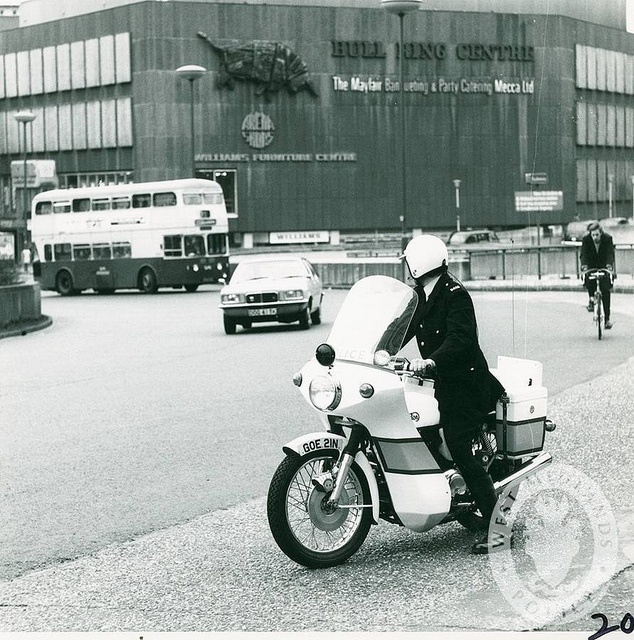Describe the objects in this image and their specific colors. I can see motorcycle in white, black, darkgray, and gray tones, bus in white, black, gray, and darkgray tones, people in white, black, darkgray, and gray tones, car in white, black, darkgray, and gray tones, and people in white, black, gray, darkgray, and lightgray tones in this image. 